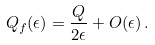Convert formula to latex. <formula><loc_0><loc_0><loc_500><loc_500>Q _ { f } ( \epsilon ) = \frac { Q } { 2 \epsilon } + O ( \epsilon ) \, .</formula> 